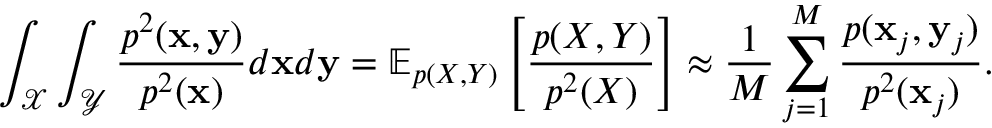Convert formula to latex. <formula><loc_0><loc_0><loc_500><loc_500>\int _ { \mathcal { X } } \int _ { \mathcal { Y } } \frac { p ^ { 2 } ( x , y ) } { p ^ { 2 } ( x ) } d x d y = \mathbb { E } _ { p ( X , Y ) } \left [ \frac { p ( X , Y ) } { p ^ { 2 } ( X ) } \right ] \approx \frac { 1 } { M } \sum _ { j = 1 } ^ { M } \frac { p ( x _ { j } , y _ { j } ) } { p ^ { 2 } ( x _ { j } ) } .</formula> 